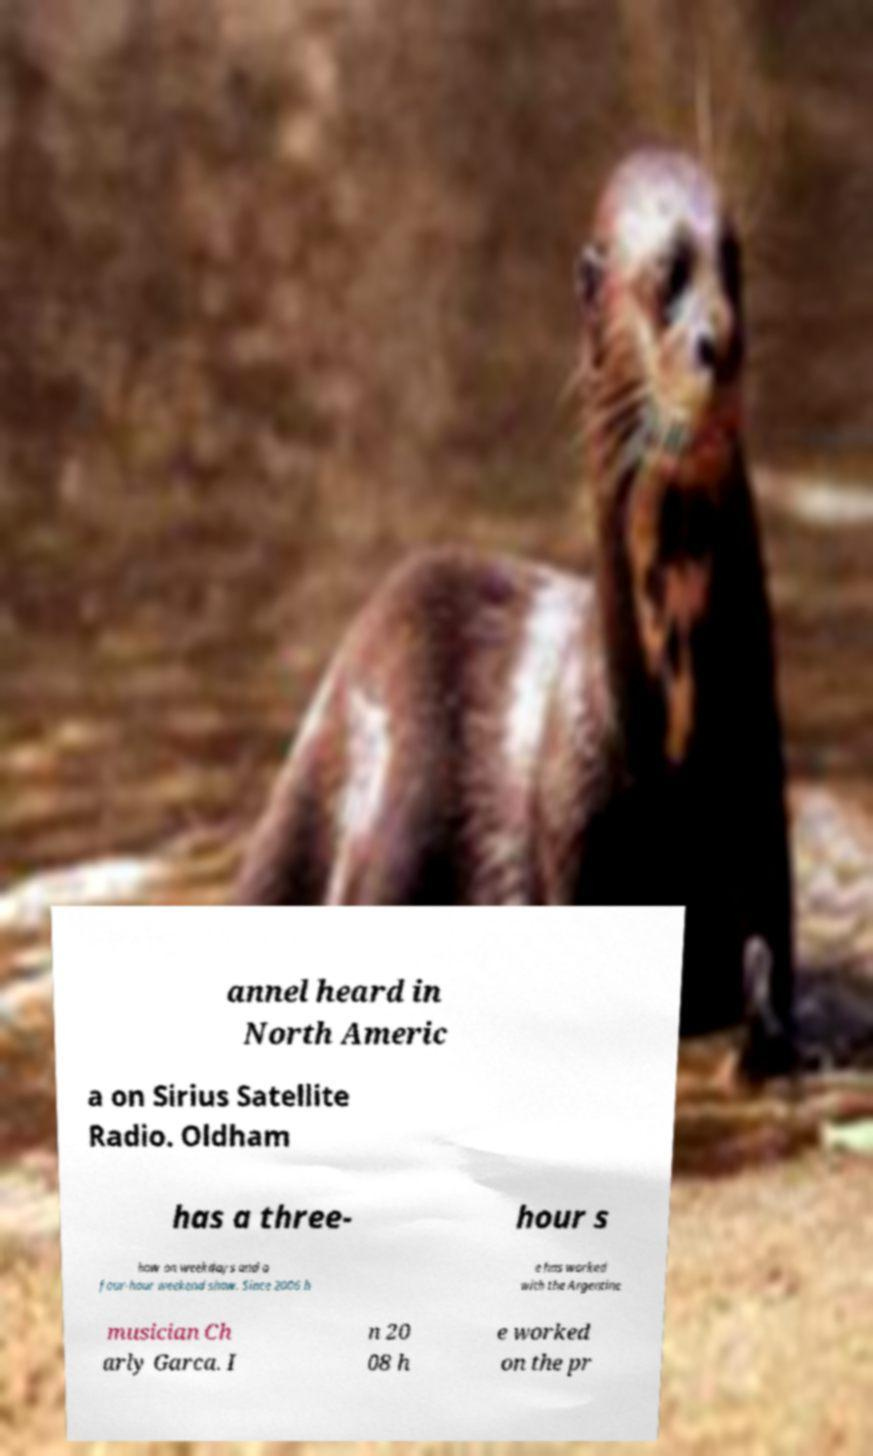Please identify and transcribe the text found in this image. annel heard in North Americ a on Sirius Satellite Radio. Oldham has a three- hour s how on weekdays and a four-hour weekend show. Since 2006 h e has worked with the Argentine musician Ch arly Garca. I n 20 08 h e worked on the pr 